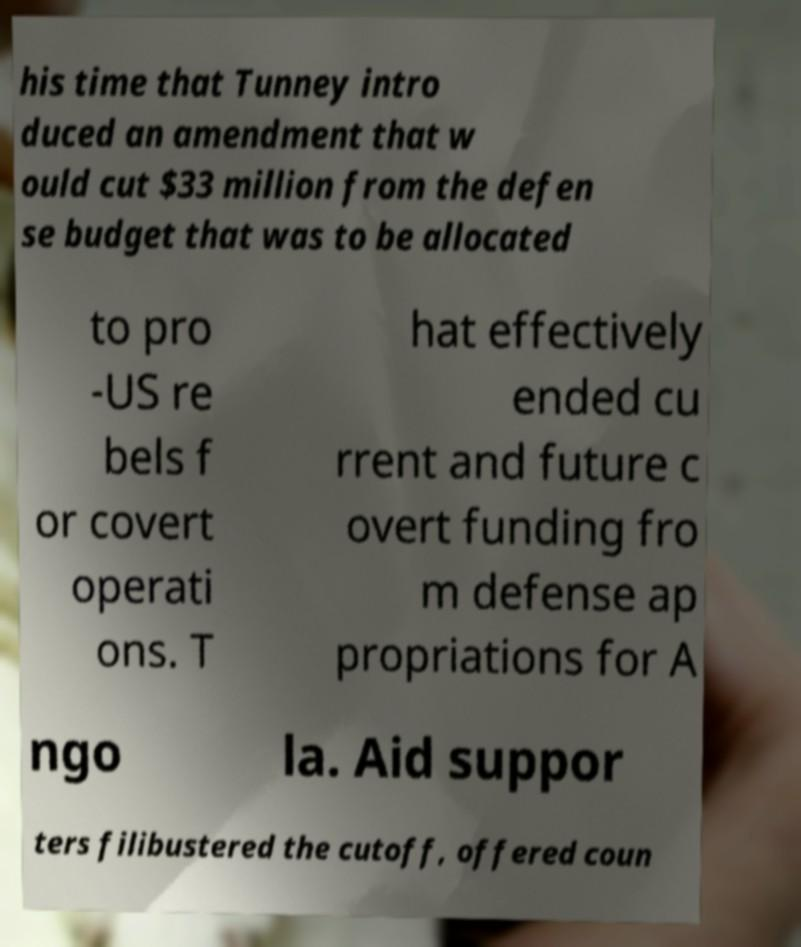I need the written content from this picture converted into text. Can you do that? his time that Tunney intro duced an amendment that w ould cut $33 million from the defen se budget that was to be allocated to pro -US re bels f or covert operati ons. T hat effectively ended cu rrent and future c overt funding fro m defense ap propriations for A ngo la. Aid suppor ters filibustered the cutoff, offered coun 